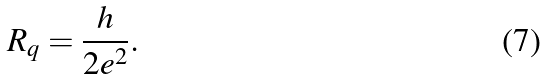<formula> <loc_0><loc_0><loc_500><loc_500>R _ { q } = \frac { h } { 2 e ^ { 2 } } .</formula> 